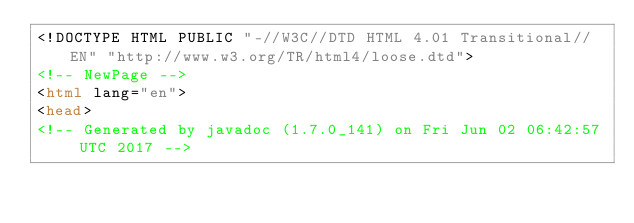Convert code to text. <code><loc_0><loc_0><loc_500><loc_500><_HTML_><!DOCTYPE HTML PUBLIC "-//W3C//DTD HTML 4.01 Transitional//EN" "http://www.w3.org/TR/html4/loose.dtd">
<!-- NewPage -->
<html lang="en">
<head>
<!-- Generated by javadoc (1.7.0_141) on Fri Jun 02 06:42:57 UTC 2017 --></code> 